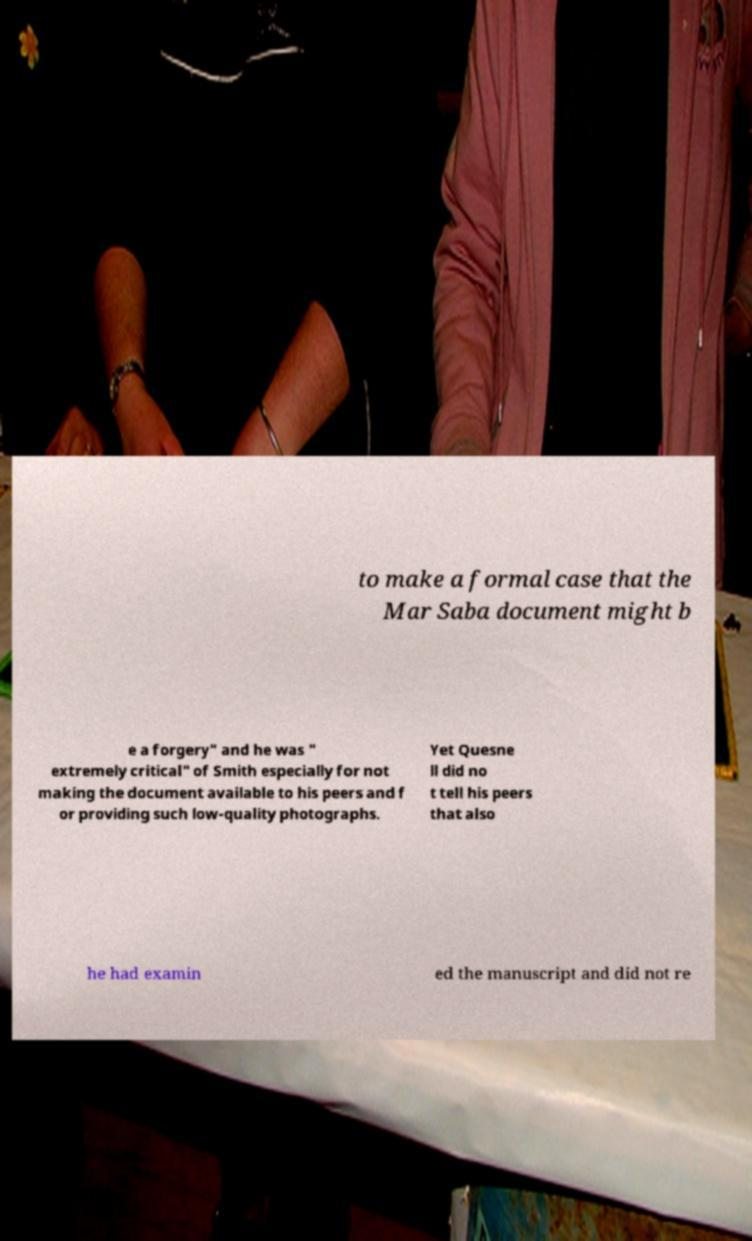Could you extract and type out the text from this image? to make a formal case that the Mar Saba document might b e a forgery" and he was " extremely critical" of Smith especially for not making the document available to his peers and f or providing such low-quality photographs. Yet Quesne ll did no t tell his peers that also he had examin ed the manuscript and did not re 